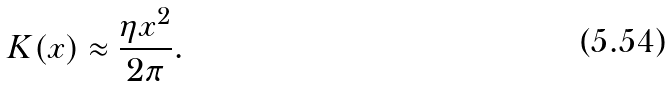Convert formula to latex. <formula><loc_0><loc_0><loc_500><loc_500>K ( { x } ) \approx \frac { \eta { x } ^ { 2 } } { 2 \pi } .</formula> 